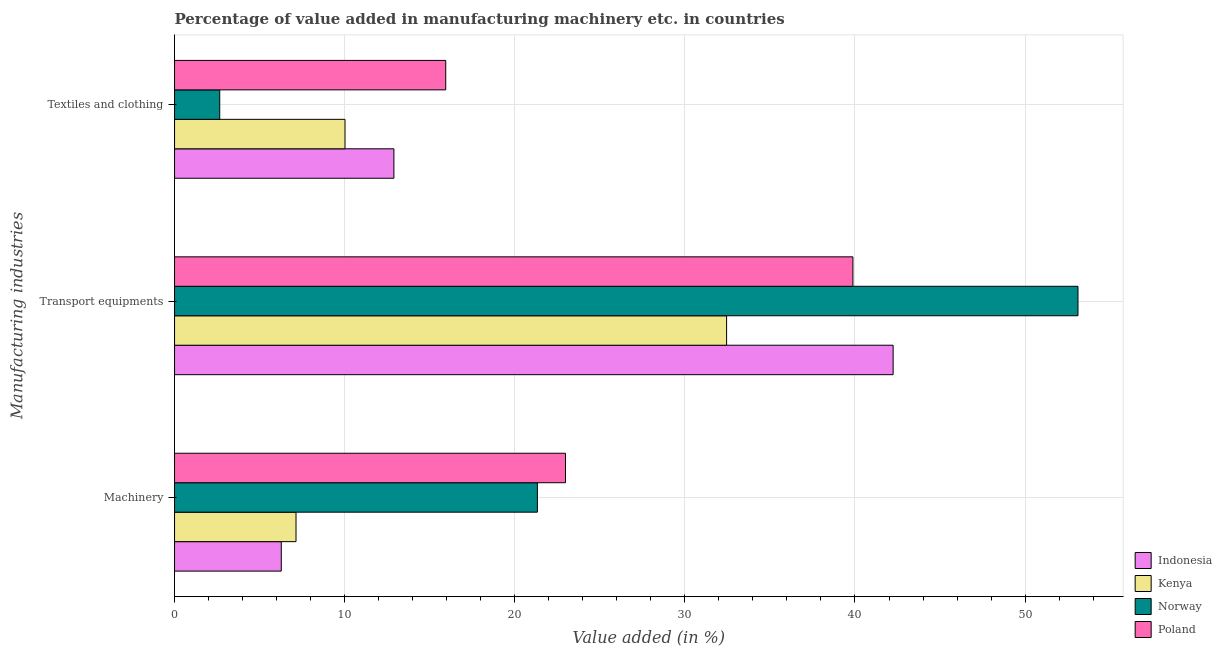How many different coloured bars are there?
Provide a succinct answer. 4. Are the number of bars on each tick of the Y-axis equal?
Your answer should be very brief. Yes. What is the label of the 1st group of bars from the top?
Give a very brief answer. Textiles and clothing. What is the value added in manufacturing textile and clothing in Kenya?
Give a very brief answer. 10.02. Across all countries, what is the maximum value added in manufacturing machinery?
Your answer should be compact. 22.98. Across all countries, what is the minimum value added in manufacturing transport equipments?
Keep it short and to the point. 32.45. What is the total value added in manufacturing transport equipments in the graph?
Provide a short and direct response. 167.68. What is the difference between the value added in manufacturing machinery in Norway and that in Kenya?
Give a very brief answer. 14.19. What is the difference between the value added in manufacturing textile and clothing in Indonesia and the value added in manufacturing transport equipments in Kenya?
Give a very brief answer. -19.56. What is the average value added in manufacturing transport equipments per country?
Your response must be concise. 41.92. What is the difference between the value added in manufacturing transport equipments and value added in manufacturing textile and clothing in Poland?
Ensure brevity in your answer.  23.94. What is the ratio of the value added in manufacturing textile and clothing in Poland to that in Norway?
Offer a terse response. 6. Is the difference between the value added in manufacturing textile and clothing in Poland and Indonesia greater than the difference between the value added in manufacturing machinery in Poland and Indonesia?
Your answer should be compact. No. What is the difference between the highest and the second highest value added in manufacturing machinery?
Your answer should be very brief. 1.65. What is the difference between the highest and the lowest value added in manufacturing machinery?
Keep it short and to the point. 16.71. Is the sum of the value added in manufacturing machinery in Kenya and Norway greater than the maximum value added in manufacturing transport equipments across all countries?
Give a very brief answer. No. What does the 3rd bar from the top in Machinery represents?
Offer a very short reply. Kenya. How many bars are there?
Give a very brief answer. 12. Are all the bars in the graph horizontal?
Your response must be concise. Yes. How many countries are there in the graph?
Your answer should be compact. 4. What is the difference between two consecutive major ticks on the X-axis?
Offer a terse response. 10. Does the graph contain any zero values?
Your answer should be very brief. No. Where does the legend appear in the graph?
Provide a short and direct response. Bottom right. How are the legend labels stacked?
Your response must be concise. Vertical. What is the title of the graph?
Give a very brief answer. Percentage of value added in manufacturing machinery etc. in countries. What is the label or title of the X-axis?
Make the answer very short. Value added (in %). What is the label or title of the Y-axis?
Your answer should be very brief. Manufacturing industries. What is the Value added (in %) in Indonesia in Machinery?
Provide a succinct answer. 6.27. What is the Value added (in %) of Kenya in Machinery?
Keep it short and to the point. 7.14. What is the Value added (in %) in Norway in Machinery?
Give a very brief answer. 21.33. What is the Value added (in %) of Poland in Machinery?
Offer a terse response. 22.98. What is the Value added (in %) of Indonesia in Transport equipments?
Make the answer very short. 42.24. What is the Value added (in %) in Kenya in Transport equipments?
Ensure brevity in your answer.  32.45. What is the Value added (in %) in Norway in Transport equipments?
Ensure brevity in your answer.  53.11. What is the Value added (in %) in Poland in Transport equipments?
Make the answer very short. 39.88. What is the Value added (in %) in Indonesia in Textiles and clothing?
Provide a short and direct response. 12.9. What is the Value added (in %) in Kenya in Textiles and clothing?
Provide a short and direct response. 10.02. What is the Value added (in %) in Norway in Textiles and clothing?
Ensure brevity in your answer.  2.66. What is the Value added (in %) of Poland in Textiles and clothing?
Ensure brevity in your answer.  15.94. Across all Manufacturing industries, what is the maximum Value added (in %) in Indonesia?
Make the answer very short. 42.24. Across all Manufacturing industries, what is the maximum Value added (in %) in Kenya?
Give a very brief answer. 32.45. Across all Manufacturing industries, what is the maximum Value added (in %) of Norway?
Keep it short and to the point. 53.11. Across all Manufacturing industries, what is the maximum Value added (in %) of Poland?
Your answer should be compact. 39.88. Across all Manufacturing industries, what is the minimum Value added (in %) of Indonesia?
Provide a succinct answer. 6.27. Across all Manufacturing industries, what is the minimum Value added (in %) of Kenya?
Your answer should be very brief. 7.14. Across all Manufacturing industries, what is the minimum Value added (in %) of Norway?
Provide a succinct answer. 2.66. Across all Manufacturing industries, what is the minimum Value added (in %) in Poland?
Make the answer very short. 15.94. What is the total Value added (in %) of Indonesia in the graph?
Provide a short and direct response. 61.41. What is the total Value added (in %) in Kenya in the graph?
Ensure brevity in your answer.  49.61. What is the total Value added (in %) in Norway in the graph?
Your response must be concise. 77.09. What is the total Value added (in %) in Poland in the graph?
Keep it short and to the point. 78.8. What is the difference between the Value added (in %) in Indonesia in Machinery and that in Transport equipments?
Make the answer very short. -35.97. What is the difference between the Value added (in %) of Kenya in Machinery and that in Transport equipments?
Your response must be concise. -25.31. What is the difference between the Value added (in %) of Norway in Machinery and that in Transport equipments?
Offer a very short reply. -31.78. What is the difference between the Value added (in %) of Poland in Machinery and that in Transport equipments?
Make the answer very short. -16.9. What is the difference between the Value added (in %) in Indonesia in Machinery and that in Textiles and clothing?
Your response must be concise. -6.62. What is the difference between the Value added (in %) in Kenya in Machinery and that in Textiles and clothing?
Your response must be concise. -2.88. What is the difference between the Value added (in %) in Norway in Machinery and that in Textiles and clothing?
Ensure brevity in your answer.  18.67. What is the difference between the Value added (in %) in Poland in Machinery and that in Textiles and clothing?
Offer a terse response. 7.04. What is the difference between the Value added (in %) of Indonesia in Transport equipments and that in Textiles and clothing?
Offer a very short reply. 29.35. What is the difference between the Value added (in %) in Kenya in Transport equipments and that in Textiles and clothing?
Your response must be concise. 22.43. What is the difference between the Value added (in %) of Norway in Transport equipments and that in Textiles and clothing?
Offer a very short reply. 50.45. What is the difference between the Value added (in %) of Poland in Transport equipments and that in Textiles and clothing?
Provide a short and direct response. 23.94. What is the difference between the Value added (in %) of Indonesia in Machinery and the Value added (in %) of Kenya in Transport equipments?
Offer a very short reply. -26.18. What is the difference between the Value added (in %) in Indonesia in Machinery and the Value added (in %) in Norway in Transport equipments?
Offer a very short reply. -46.83. What is the difference between the Value added (in %) of Indonesia in Machinery and the Value added (in %) of Poland in Transport equipments?
Offer a very short reply. -33.6. What is the difference between the Value added (in %) of Kenya in Machinery and the Value added (in %) of Norway in Transport equipments?
Your answer should be very brief. -45.97. What is the difference between the Value added (in %) in Kenya in Machinery and the Value added (in %) in Poland in Transport equipments?
Offer a terse response. -32.74. What is the difference between the Value added (in %) of Norway in Machinery and the Value added (in %) of Poland in Transport equipments?
Provide a short and direct response. -18.55. What is the difference between the Value added (in %) of Indonesia in Machinery and the Value added (in %) of Kenya in Textiles and clothing?
Make the answer very short. -3.75. What is the difference between the Value added (in %) in Indonesia in Machinery and the Value added (in %) in Norway in Textiles and clothing?
Offer a very short reply. 3.62. What is the difference between the Value added (in %) of Indonesia in Machinery and the Value added (in %) of Poland in Textiles and clothing?
Keep it short and to the point. -9.67. What is the difference between the Value added (in %) in Kenya in Machinery and the Value added (in %) in Norway in Textiles and clothing?
Provide a succinct answer. 4.48. What is the difference between the Value added (in %) of Kenya in Machinery and the Value added (in %) of Poland in Textiles and clothing?
Your answer should be compact. -8.8. What is the difference between the Value added (in %) in Norway in Machinery and the Value added (in %) in Poland in Textiles and clothing?
Keep it short and to the point. 5.39. What is the difference between the Value added (in %) in Indonesia in Transport equipments and the Value added (in %) in Kenya in Textiles and clothing?
Make the answer very short. 32.22. What is the difference between the Value added (in %) of Indonesia in Transport equipments and the Value added (in %) of Norway in Textiles and clothing?
Offer a very short reply. 39.59. What is the difference between the Value added (in %) in Indonesia in Transport equipments and the Value added (in %) in Poland in Textiles and clothing?
Offer a very short reply. 26.3. What is the difference between the Value added (in %) of Kenya in Transport equipments and the Value added (in %) of Norway in Textiles and clothing?
Your answer should be very brief. 29.8. What is the difference between the Value added (in %) in Kenya in Transport equipments and the Value added (in %) in Poland in Textiles and clothing?
Provide a short and direct response. 16.51. What is the difference between the Value added (in %) in Norway in Transport equipments and the Value added (in %) in Poland in Textiles and clothing?
Make the answer very short. 37.17. What is the average Value added (in %) of Indonesia per Manufacturing industries?
Make the answer very short. 20.47. What is the average Value added (in %) of Kenya per Manufacturing industries?
Offer a terse response. 16.54. What is the average Value added (in %) in Norway per Manufacturing industries?
Offer a terse response. 25.7. What is the average Value added (in %) of Poland per Manufacturing industries?
Provide a succinct answer. 26.27. What is the difference between the Value added (in %) in Indonesia and Value added (in %) in Kenya in Machinery?
Provide a succinct answer. -0.87. What is the difference between the Value added (in %) in Indonesia and Value added (in %) in Norway in Machinery?
Offer a very short reply. -15.06. What is the difference between the Value added (in %) in Indonesia and Value added (in %) in Poland in Machinery?
Offer a terse response. -16.71. What is the difference between the Value added (in %) of Kenya and Value added (in %) of Norway in Machinery?
Ensure brevity in your answer.  -14.19. What is the difference between the Value added (in %) in Kenya and Value added (in %) in Poland in Machinery?
Keep it short and to the point. -15.84. What is the difference between the Value added (in %) in Norway and Value added (in %) in Poland in Machinery?
Keep it short and to the point. -1.65. What is the difference between the Value added (in %) of Indonesia and Value added (in %) of Kenya in Transport equipments?
Offer a very short reply. 9.79. What is the difference between the Value added (in %) in Indonesia and Value added (in %) in Norway in Transport equipments?
Offer a terse response. -10.87. What is the difference between the Value added (in %) of Indonesia and Value added (in %) of Poland in Transport equipments?
Give a very brief answer. 2.36. What is the difference between the Value added (in %) in Kenya and Value added (in %) in Norway in Transport equipments?
Offer a terse response. -20.66. What is the difference between the Value added (in %) of Kenya and Value added (in %) of Poland in Transport equipments?
Your answer should be compact. -7.43. What is the difference between the Value added (in %) in Norway and Value added (in %) in Poland in Transport equipments?
Offer a very short reply. 13.23. What is the difference between the Value added (in %) in Indonesia and Value added (in %) in Kenya in Textiles and clothing?
Give a very brief answer. 2.87. What is the difference between the Value added (in %) in Indonesia and Value added (in %) in Norway in Textiles and clothing?
Offer a terse response. 10.24. What is the difference between the Value added (in %) of Indonesia and Value added (in %) of Poland in Textiles and clothing?
Offer a very short reply. -3.05. What is the difference between the Value added (in %) of Kenya and Value added (in %) of Norway in Textiles and clothing?
Provide a short and direct response. 7.36. What is the difference between the Value added (in %) in Kenya and Value added (in %) in Poland in Textiles and clothing?
Offer a very short reply. -5.92. What is the difference between the Value added (in %) of Norway and Value added (in %) of Poland in Textiles and clothing?
Your answer should be compact. -13.29. What is the ratio of the Value added (in %) in Indonesia in Machinery to that in Transport equipments?
Ensure brevity in your answer.  0.15. What is the ratio of the Value added (in %) of Kenya in Machinery to that in Transport equipments?
Your response must be concise. 0.22. What is the ratio of the Value added (in %) in Norway in Machinery to that in Transport equipments?
Provide a short and direct response. 0.4. What is the ratio of the Value added (in %) of Poland in Machinery to that in Transport equipments?
Your answer should be compact. 0.58. What is the ratio of the Value added (in %) of Indonesia in Machinery to that in Textiles and clothing?
Give a very brief answer. 0.49. What is the ratio of the Value added (in %) in Kenya in Machinery to that in Textiles and clothing?
Your response must be concise. 0.71. What is the ratio of the Value added (in %) of Norway in Machinery to that in Textiles and clothing?
Offer a terse response. 8.03. What is the ratio of the Value added (in %) in Poland in Machinery to that in Textiles and clothing?
Provide a short and direct response. 1.44. What is the ratio of the Value added (in %) of Indonesia in Transport equipments to that in Textiles and clothing?
Offer a terse response. 3.28. What is the ratio of the Value added (in %) in Kenya in Transport equipments to that in Textiles and clothing?
Offer a terse response. 3.24. What is the ratio of the Value added (in %) of Norway in Transport equipments to that in Textiles and clothing?
Provide a short and direct response. 20. What is the ratio of the Value added (in %) in Poland in Transport equipments to that in Textiles and clothing?
Keep it short and to the point. 2.5. What is the difference between the highest and the second highest Value added (in %) of Indonesia?
Offer a terse response. 29.35. What is the difference between the highest and the second highest Value added (in %) of Kenya?
Your response must be concise. 22.43. What is the difference between the highest and the second highest Value added (in %) in Norway?
Ensure brevity in your answer.  31.78. What is the difference between the highest and the second highest Value added (in %) in Poland?
Keep it short and to the point. 16.9. What is the difference between the highest and the lowest Value added (in %) in Indonesia?
Your answer should be very brief. 35.97. What is the difference between the highest and the lowest Value added (in %) in Kenya?
Provide a succinct answer. 25.31. What is the difference between the highest and the lowest Value added (in %) in Norway?
Offer a terse response. 50.45. What is the difference between the highest and the lowest Value added (in %) of Poland?
Provide a short and direct response. 23.94. 